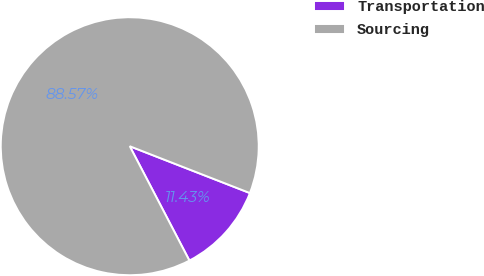<chart> <loc_0><loc_0><loc_500><loc_500><pie_chart><fcel>Transportation<fcel>Sourcing<nl><fcel>11.43%<fcel>88.57%<nl></chart> 